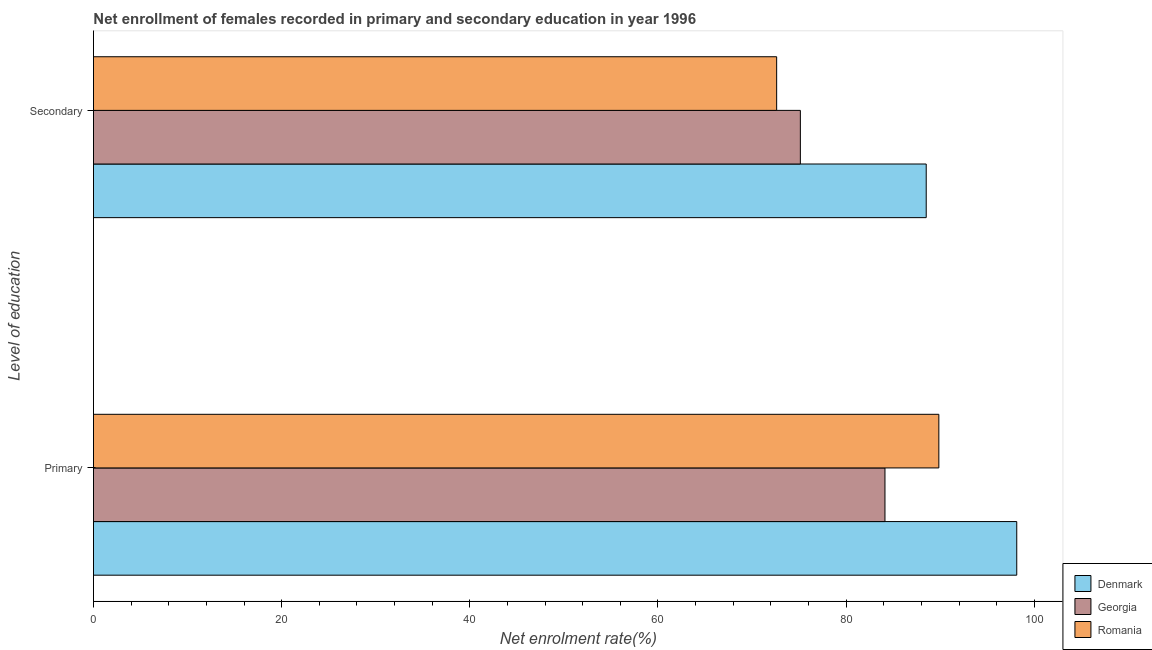How many bars are there on the 1st tick from the bottom?
Provide a succinct answer. 3. What is the label of the 1st group of bars from the top?
Provide a short and direct response. Secondary. What is the enrollment rate in secondary education in Denmark?
Offer a very short reply. 88.51. Across all countries, what is the maximum enrollment rate in primary education?
Make the answer very short. 98.14. Across all countries, what is the minimum enrollment rate in secondary education?
Keep it short and to the point. 72.62. In which country was the enrollment rate in primary education maximum?
Give a very brief answer. Denmark. In which country was the enrollment rate in primary education minimum?
Make the answer very short. Georgia. What is the total enrollment rate in secondary education in the graph?
Ensure brevity in your answer.  236.27. What is the difference between the enrollment rate in secondary education in Georgia and that in Denmark?
Your answer should be compact. -13.38. What is the difference between the enrollment rate in primary education in Georgia and the enrollment rate in secondary education in Romania?
Provide a succinct answer. 11.51. What is the average enrollment rate in primary education per country?
Ensure brevity in your answer.  90.71. What is the difference between the enrollment rate in secondary education and enrollment rate in primary education in Georgia?
Keep it short and to the point. -8.99. What is the ratio of the enrollment rate in primary education in Romania to that in Denmark?
Your answer should be very brief. 0.92. In how many countries, is the enrollment rate in secondary education greater than the average enrollment rate in secondary education taken over all countries?
Make the answer very short. 1. What does the 3rd bar from the top in Secondary represents?
Offer a terse response. Denmark. What does the 2nd bar from the bottom in Primary represents?
Keep it short and to the point. Georgia. Are all the bars in the graph horizontal?
Your answer should be very brief. Yes. How many countries are there in the graph?
Your answer should be very brief. 3. What is the difference between two consecutive major ticks on the X-axis?
Your answer should be compact. 20. Are the values on the major ticks of X-axis written in scientific E-notation?
Make the answer very short. No. Does the graph contain any zero values?
Offer a terse response. No. How are the legend labels stacked?
Give a very brief answer. Vertical. What is the title of the graph?
Ensure brevity in your answer.  Net enrollment of females recorded in primary and secondary education in year 1996. Does "Macao" appear as one of the legend labels in the graph?
Provide a succinct answer. No. What is the label or title of the X-axis?
Offer a very short reply. Net enrolment rate(%). What is the label or title of the Y-axis?
Ensure brevity in your answer.  Level of education. What is the Net enrolment rate(%) in Denmark in Primary?
Keep it short and to the point. 98.14. What is the Net enrolment rate(%) in Georgia in Primary?
Keep it short and to the point. 84.13. What is the Net enrolment rate(%) in Romania in Primary?
Provide a short and direct response. 89.86. What is the Net enrolment rate(%) of Denmark in Secondary?
Provide a short and direct response. 88.51. What is the Net enrolment rate(%) of Georgia in Secondary?
Your answer should be very brief. 75.14. What is the Net enrolment rate(%) in Romania in Secondary?
Make the answer very short. 72.62. Across all Level of education, what is the maximum Net enrolment rate(%) in Denmark?
Provide a succinct answer. 98.14. Across all Level of education, what is the maximum Net enrolment rate(%) of Georgia?
Offer a terse response. 84.13. Across all Level of education, what is the maximum Net enrolment rate(%) of Romania?
Keep it short and to the point. 89.86. Across all Level of education, what is the minimum Net enrolment rate(%) in Denmark?
Offer a terse response. 88.51. Across all Level of education, what is the minimum Net enrolment rate(%) of Georgia?
Keep it short and to the point. 75.14. Across all Level of education, what is the minimum Net enrolment rate(%) in Romania?
Keep it short and to the point. 72.62. What is the total Net enrolment rate(%) in Denmark in the graph?
Your response must be concise. 186.65. What is the total Net enrolment rate(%) in Georgia in the graph?
Ensure brevity in your answer.  159.27. What is the total Net enrolment rate(%) of Romania in the graph?
Provide a short and direct response. 162.47. What is the difference between the Net enrolment rate(%) in Denmark in Primary and that in Secondary?
Give a very brief answer. 9.62. What is the difference between the Net enrolment rate(%) in Georgia in Primary and that in Secondary?
Provide a succinct answer. 8.99. What is the difference between the Net enrolment rate(%) in Romania in Primary and that in Secondary?
Offer a very short reply. 17.24. What is the difference between the Net enrolment rate(%) of Denmark in Primary and the Net enrolment rate(%) of Georgia in Secondary?
Offer a very short reply. 23. What is the difference between the Net enrolment rate(%) in Denmark in Primary and the Net enrolment rate(%) in Romania in Secondary?
Your answer should be compact. 25.52. What is the difference between the Net enrolment rate(%) in Georgia in Primary and the Net enrolment rate(%) in Romania in Secondary?
Provide a succinct answer. 11.51. What is the average Net enrolment rate(%) in Denmark per Level of education?
Provide a short and direct response. 93.33. What is the average Net enrolment rate(%) in Georgia per Level of education?
Your answer should be very brief. 79.63. What is the average Net enrolment rate(%) in Romania per Level of education?
Ensure brevity in your answer.  81.24. What is the difference between the Net enrolment rate(%) of Denmark and Net enrolment rate(%) of Georgia in Primary?
Offer a terse response. 14.01. What is the difference between the Net enrolment rate(%) in Denmark and Net enrolment rate(%) in Romania in Primary?
Your response must be concise. 8.28. What is the difference between the Net enrolment rate(%) in Georgia and Net enrolment rate(%) in Romania in Primary?
Give a very brief answer. -5.73. What is the difference between the Net enrolment rate(%) in Denmark and Net enrolment rate(%) in Georgia in Secondary?
Offer a terse response. 13.38. What is the difference between the Net enrolment rate(%) in Denmark and Net enrolment rate(%) in Romania in Secondary?
Offer a terse response. 15.9. What is the difference between the Net enrolment rate(%) in Georgia and Net enrolment rate(%) in Romania in Secondary?
Offer a terse response. 2.52. What is the ratio of the Net enrolment rate(%) in Denmark in Primary to that in Secondary?
Your answer should be very brief. 1.11. What is the ratio of the Net enrolment rate(%) in Georgia in Primary to that in Secondary?
Offer a very short reply. 1.12. What is the ratio of the Net enrolment rate(%) of Romania in Primary to that in Secondary?
Make the answer very short. 1.24. What is the difference between the highest and the second highest Net enrolment rate(%) in Denmark?
Provide a short and direct response. 9.62. What is the difference between the highest and the second highest Net enrolment rate(%) of Georgia?
Offer a very short reply. 8.99. What is the difference between the highest and the second highest Net enrolment rate(%) of Romania?
Offer a very short reply. 17.24. What is the difference between the highest and the lowest Net enrolment rate(%) of Denmark?
Your answer should be very brief. 9.62. What is the difference between the highest and the lowest Net enrolment rate(%) in Georgia?
Provide a short and direct response. 8.99. What is the difference between the highest and the lowest Net enrolment rate(%) in Romania?
Make the answer very short. 17.24. 